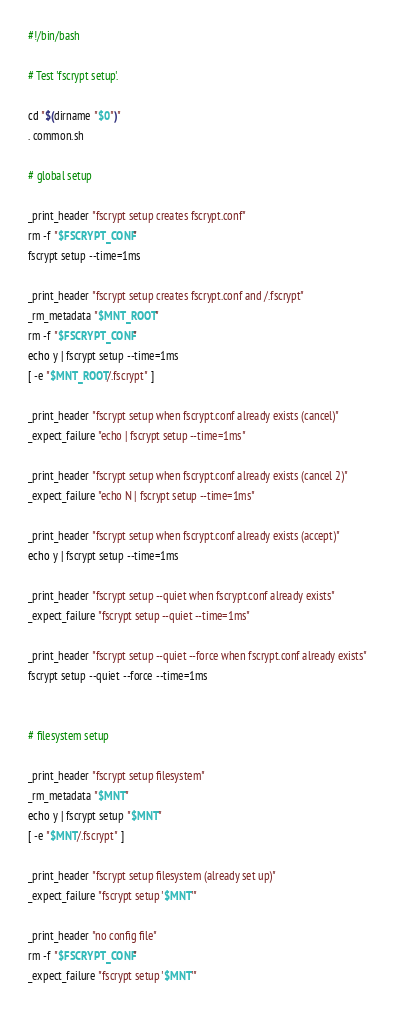<code> <loc_0><loc_0><loc_500><loc_500><_Bash_>#!/bin/bash

# Test 'fscrypt setup'.

cd "$(dirname "$0")"
. common.sh

# global setup

_print_header "fscrypt setup creates fscrypt.conf"
rm -f "$FSCRYPT_CONF"
fscrypt setup --time=1ms

_print_header "fscrypt setup creates fscrypt.conf and /.fscrypt"
_rm_metadata "$MNT_ROOT"
rm -f "$FSCRYPT_CONF"
echo y | fscrypt setup --time=1ms
[ -e "$MNT_ROOT/.fscrypt" ]

_print_header "fscrypt setup when fscrypt.conf already exists (cancel)"
_expect_failure "echo | fscrypt setup --time=1ms"

_print_header "fscrypt setup when fscrypt.conf already exists (cancel 2)"
_expect_failure "echo N | fscrypt setup --time=1ms"

_print_header "fscrypt setup when fscrypt.conf already exists (accept)"
echo y | fscrypt setup --time=1ms

_print_header "fscrypt setup --quiet when fscrypt.conf already exists"
_expect_failure "fscrypt setup --quiet --time=1ms"

_print_header "fscrypt setup --quiet --force when fscrypt.conf already exists"
fscrypt setup --quiet --force --time=1ms


# filesystem setup

_print_header "fscrypt setup filesystem"
_rm_metadata "$MNT"
echo y | fscrypt setup "$MNT"
[ -e "$MNT/.fscrypt" ]

_print_header "fscrypt setup filesystem (already set up)"
_expect_failure "fscrypt setup '$MNT'"

_print_header "no config file"
rm -f "$FSCRYPT_CONF"
_expect_failure "fscrypt setup '$MNT'"
</code> 